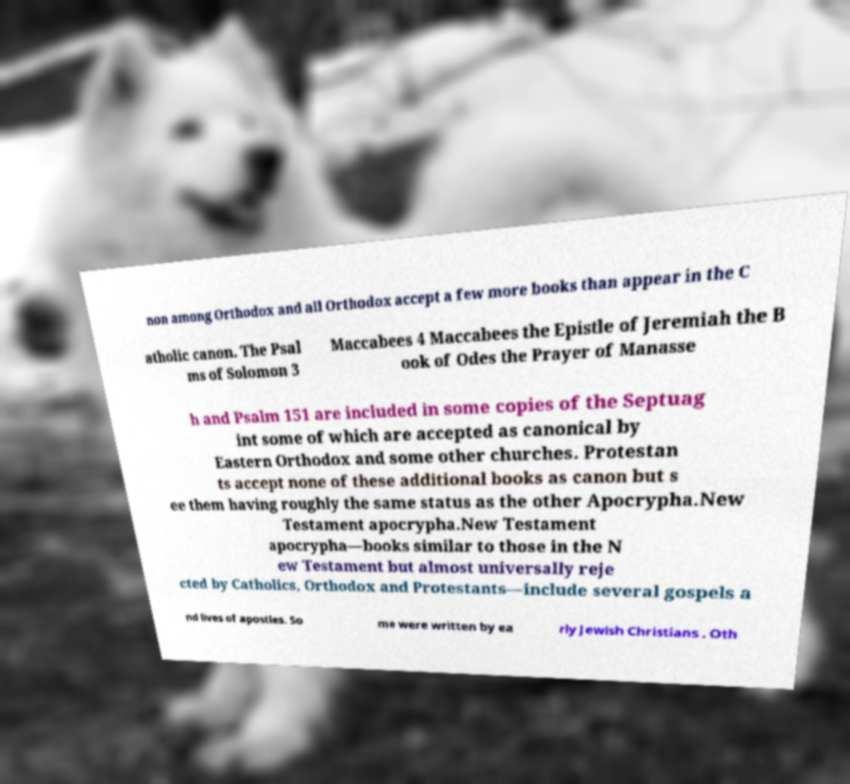There's text embedded in this image that I need extracted. Can you transcribe it verbatim? non among Orthodox and all Orthodox accept a few more books than appear in the C atholic canon. The Psal ms of Solomon 3 Maccabees 4 Maccabees the Epistle of Jeremiah the B ook of Odes the Prayer of Manasse h and Psalm 151 are included in some copies of the Septuag int some of which are accepted as canonical by Eastern Orthodox and some other churches. Protestan ts accept none of these additional books as canon but s ee them having roughly the same status as the other Apocrypha.New Testament apocrypha.New Testament apocrypha—books similar to those in the N ew Testament but almost universally reje cted by Catholics, Orthodox and Protestants—include several gospels a nd lives of apostles. So me were written by ea rly Jewish Christians . Oth 